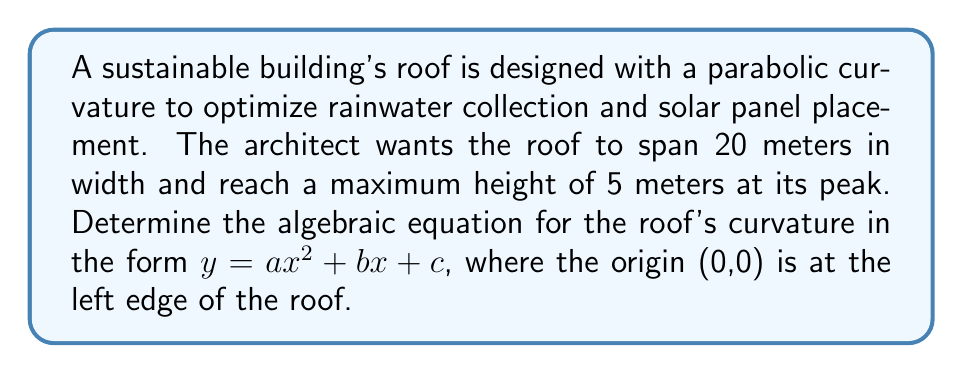Help me with this question. Let's approach this step-by-step:

1) We know the parabola passes through three points:
   (0,0) - left edge
   (10,5) - peak (midpoint)
   (20,0) - right edge

2) The general form of a parabola is $y = ax^2 + bx + c$

3) Since (0,0) is on the curve, we can deduce that $c = 0$

4) Now our equation is $y = ax^2 + bx$

5) Let's use the other two points to create a system of equations:

   For (10,5): $5 = 100a + 10b$
   For (20,0): $0 = 400a + 20b$

6) From the second equation: $20b = -400a$, or $b = -20a$

7) Substitute this into the first equation:
   $5 = 100a + 10(-20a)$
   $5 = 100a - 200a = -100a$

8) Solve for $a$:
   $a = -\frac{5}{100} = -0.05$

9) Now we can find $b$:
   $b = -20(-0.05) = 1$

10) Therefore, our final equation is:
    $y = -0.05x^2 + x$

We can verify this passes through all three points:
(0,0): $y = -0.05(0)^2 + 0 = 0$
(10,5): $y = -0.05(10)^2 + 10 = -5 + 10 = 5$
(20,0): $y = -0.05(20)^2 + 20 = -20 + 20 = 0$
Answer: $y = -0.05x^2 + x$ 